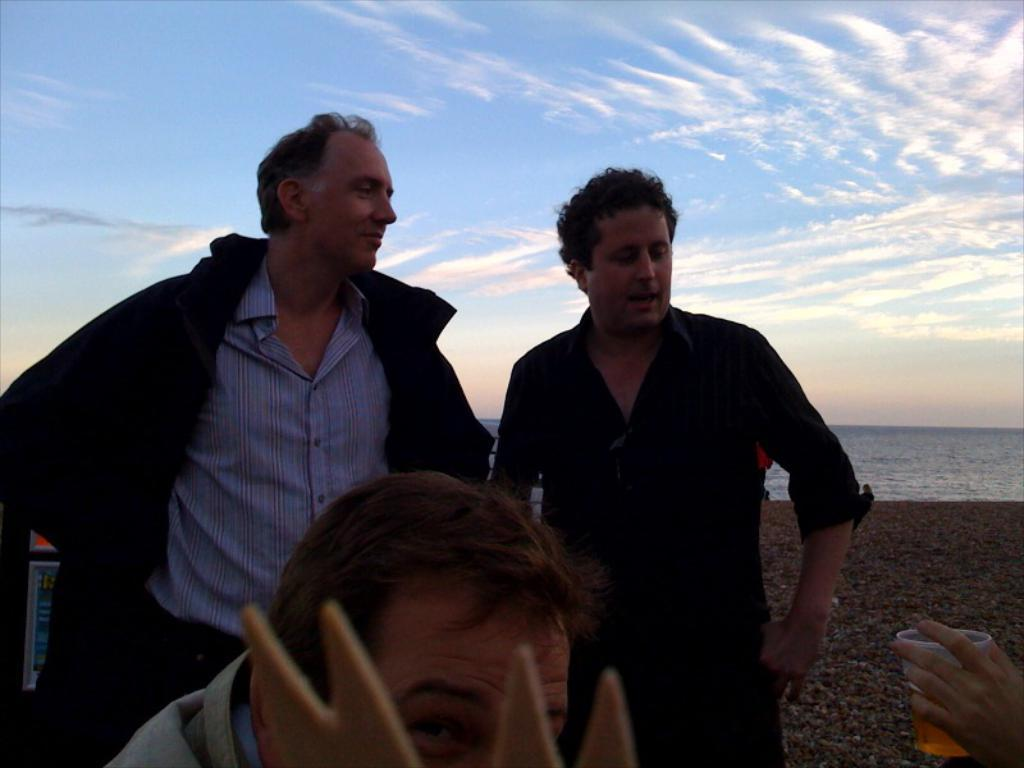What can be seen in the background of the image? There is a sky with clouds and a sea visible in the background of the image. How many people are present in the image? There are two men standing in the image, and one man is holding a glass with a drink. Can you describe the hand holding the glass with a drink? A person's hand is holding the glass with a drink in the image. What type of stamp is visible on the man's apparel in the image? There is no stamp visible on the man's apparel in the image. What is the title of the book the man is reading in the image? There is no book or reading material present in the image. 